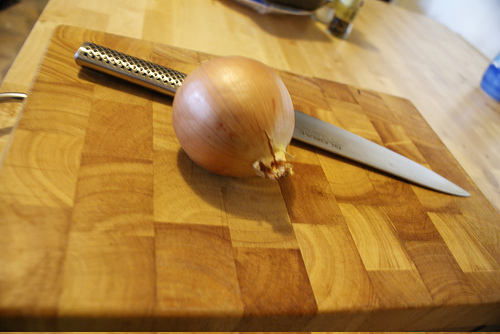<image>
Is the onion behind the knife? No. The onion is not behind the knife. From this viewpoint, the onion appears to be positioned elsewhere in the scene. 